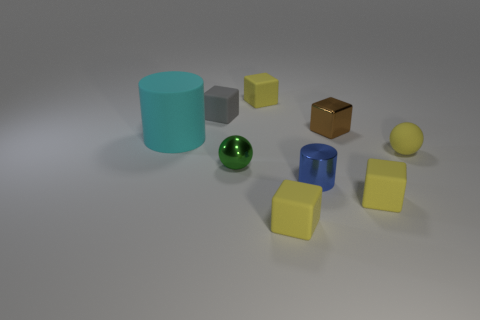The other shiny thing that is the same shape as the tiny gray thing is what size?
Provide a short and direct response. Small. Is there anything else that is the same size as the cyan matte object?
Make the answer very short. No. Is the number of cyan matte objects that are in front of the small yellow matte sphere less than the number of tiny cyan shiny spheres?
Ensure brevity in your answer.  No. Is the green thing the same shape as the gray rubber thing?
Offer a very short reply. No. There is a small shiny object that is the same shape as the large cyan thing; what color is it?
Give a very brief answer. Blue. What number of big matte cylinders have the same color as the big matte thing?
Your answer should be compact. 0. How many things are either yellow rubber blocks that are to the right of the small metal cylinder or blue metal cylinders?
Offer a terse response. 2. There is a yellow matte object behind the gray rubber thing; what size is it?
Your response must be concise. Small. Is the number of small gray rubber objects less than the number of big brown things?
Provide a short and direct response. No. Do the cylinder that is to the right of the big rubber cylinder and the tiny sphere that is behind the green metal sphere have the same material?
Offer a terse response. No. 